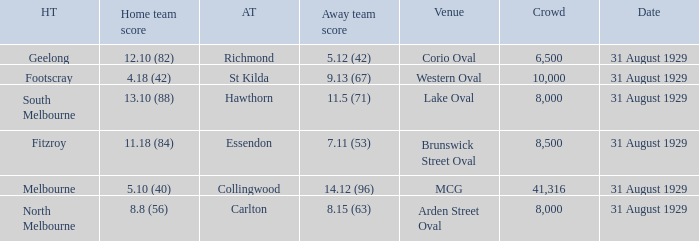What is the score of the away team when the crowd was larger than 8,000? 9.13 (67), 7.11 (53), 14.12 (96). 